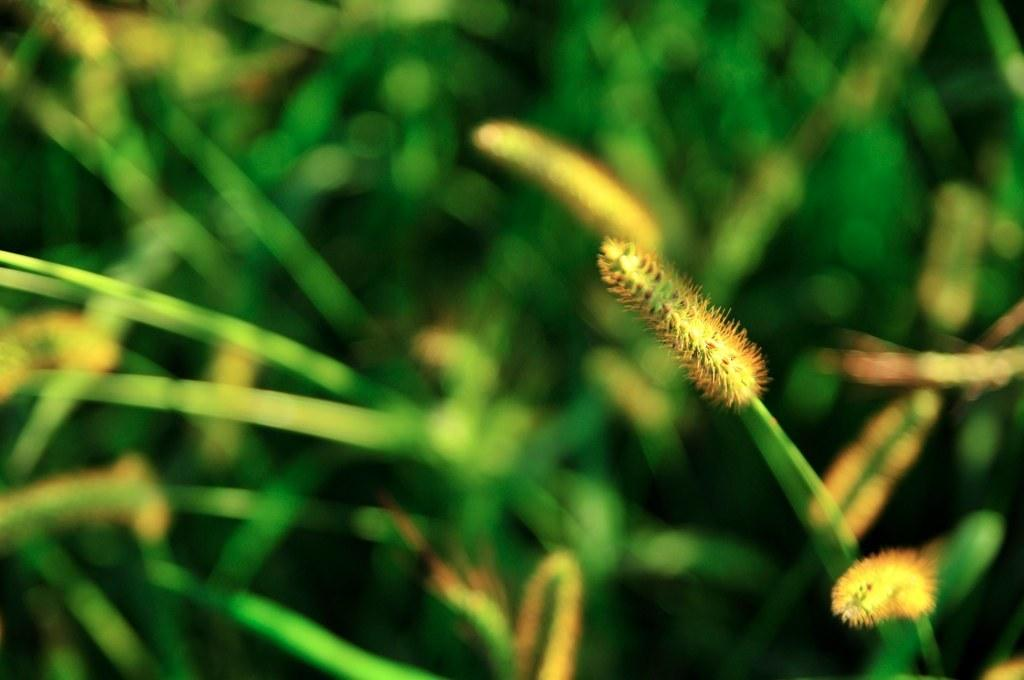What type of plants are present in the image? There are grass plants in the image. What stage of growth are the grass plants in? The grass plants have buds. What color is the hen in the image? There is no hen present in the image. 